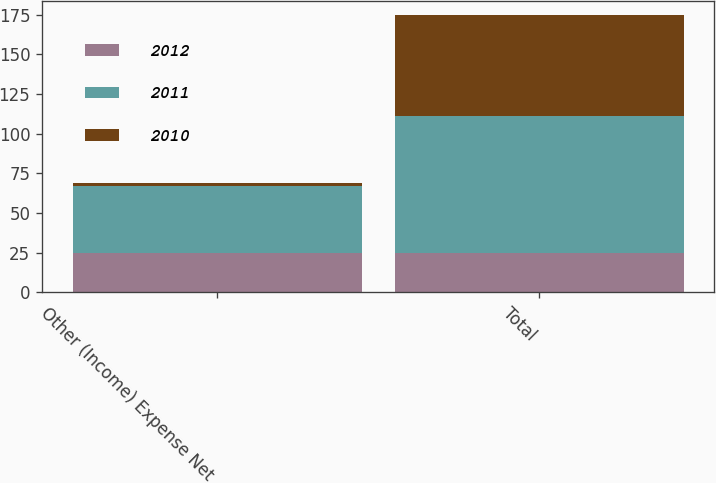<chart> <loc_0><loc_0><loc_500><loc_500><stacked_bar_chart><ecel><fcel>Other (Income) Expense Net<fcel>Total<nl><fcel>2012<fcel>25<fcel>25<nl><fcel>2011<fcel>42<fcel>86<nl><fcel>2010<fcel>2<fcel>64<nl></chart> 